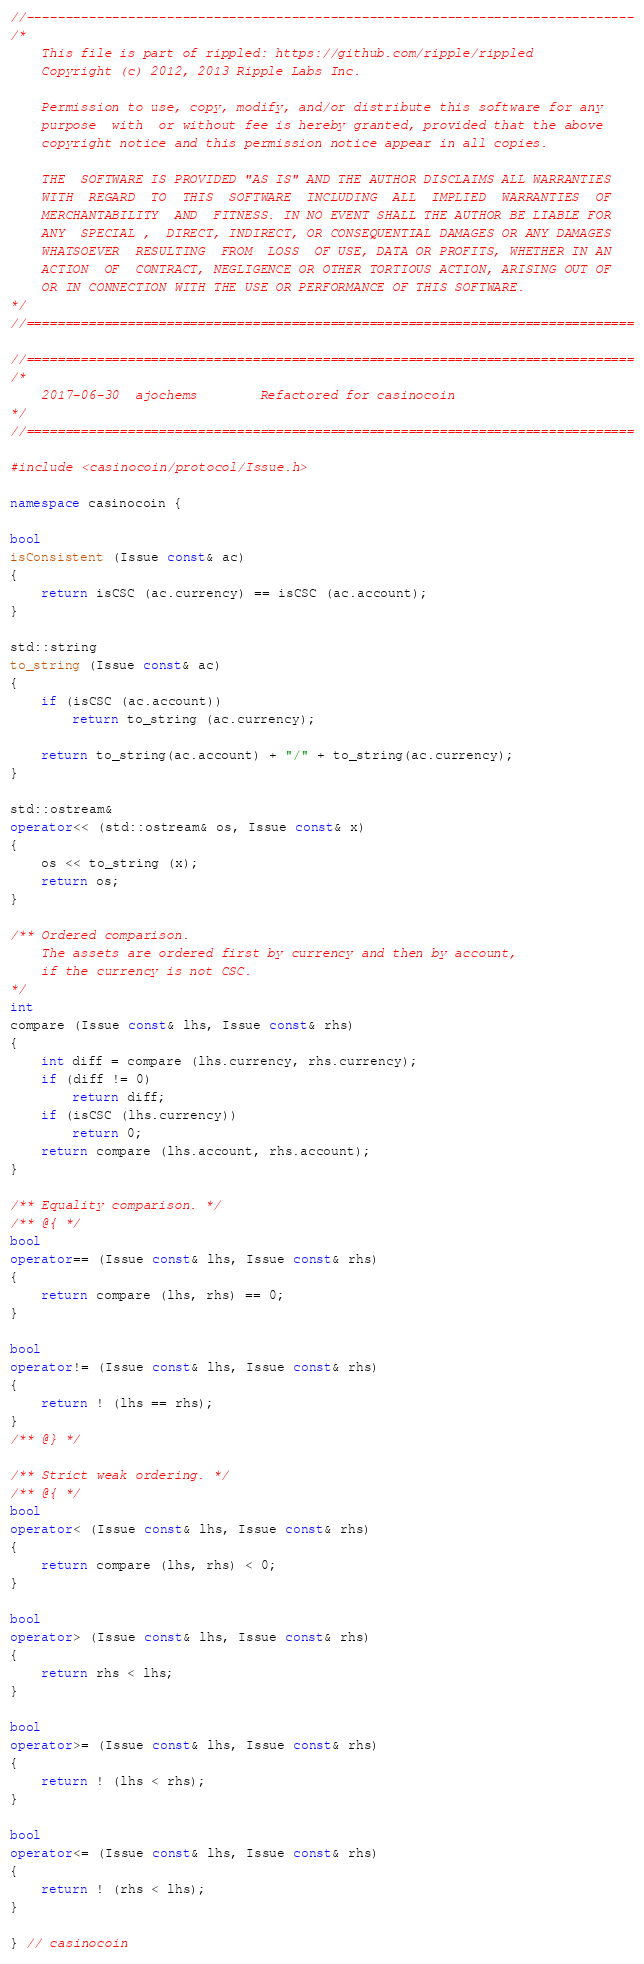<code> <loc_0><loc_0><loc_500><loc_500><_C++_>//------------------------------------------------------------------------------
/*
    This file is part of rippled: https://github.com/ripple/rippled
    Copyright (c) 2012, 2013 Ripple Labs Inc.

    Permission to use, copy, modify, and/or distribute this software for any
    purpose  with  or without fee is hereby granted, provided that the above
    copyright notice and this permission notice appear in all copies.

    THE  SOFTWARE IS PROVIDED "AS IS" AND THE AUTHOR DISCLAIMS ALL WARRANTIES
    WITH  REGARD  TO  THIS  SOFTWARE  INCLUDING  ALL  IMPLIED  WARRANTIES  OF
    MERCHANTABILITY  AND  FITNESS. IN NO EVENT SHALL THE AUTHOR BE LIABLE FOR
    ANY  SPECIAL ,  DIRECT, INDIRECT, OR CONSEQUENTIAL DAMAGES OR ANY DAMAGES
    WHATSOEVER  RESULTING  FROM  LOSS  OF USE, DATA OR PROFITS, WHETHER IN AN
    ACTION  OF  CONTRACT, NEGLIGENCE OR OTHER TORTIOUS ACTION, ARISING OUT OF
    OR IN CONNECTION WITH THE USE OR PERFORMANCE OF THIS SOFTWARE.
*/
//==============================================================================

//==============================================================================
/*
    2017-06-30  ajochems        Refactored for casinocoin
*/
//==============================================================================

#include <casinocoin/protocol/Issue.h>

namespace casinocoin {

bool
isConsistent (Issue const& ac)
{
    return isCSC (ac.currency) == isCSC (ac.account);
}

std::string
to_string (Issue const& ac)
{
    if (isCSC (ac.account))
        return to_string (ac.currency);

    return to_string(ac.account) + "/" + to_string(ac.currency);
}

std::ostream&
operator<< (std::ostream& os, Issue const& x)
{
    os << to_string (x);
    return os;
}

/** Ordered comparison.
    The assets are ordered first by currency and then by account,
    if the currency is not CSC.
*/
int
compare (Issue const& lhs, Issue const& rhs)
{
    int diff = compare (lhs.currency, rhs.currency);
    if (diff != 0)
        return diff;
    if (isCSC (lhs.currency))
        return 0;
    return compare (lhs.account, rhs.account);
}

/** Equality comparison. */
/** @{ */
bool
operator== (Issue const& lhs, Issue const& rhs)
{
    return compare (lhs, rhs) == 0;
}

bool
operator!= (Issue const& lhs, Issue const& rhs)
{
    return ! (lhs == rhs);
}
/** @} */

/** Strict weak ordering. */
/** @{ */
bool
operator< (Issue const& lhs, Issue const& rhs)
{
    return compare (lhs, rhs) < 0;
}

bool
operator> (Issue const& lhs, Issue const& rhs)
{
    return rhs < lhs;
}

bool
operator>= (Issue const& lhs, Issue const& rhs)
{
    return ! (lhs < rhs);
}

bool
operator<= (Issue const& lhs, Issue const& rhs)
{
    return ! (rhs < lhs);
}

} // casinocoin
</code> 